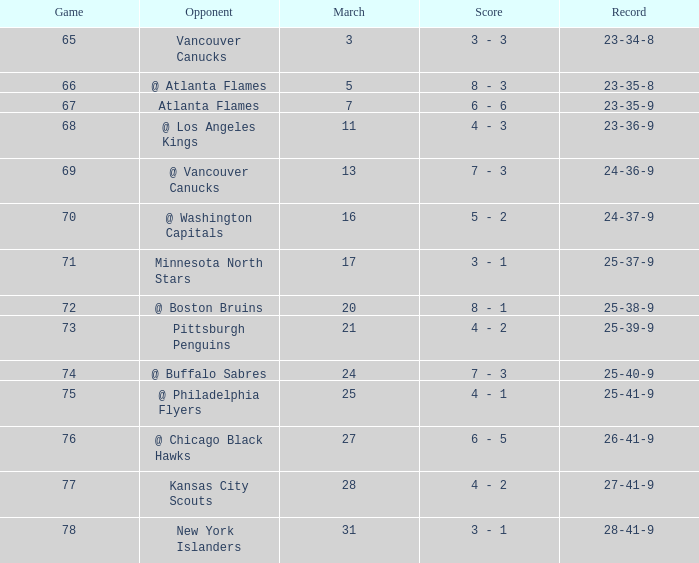What was the score when they had a 25-41-9 record? 4 - 1. 